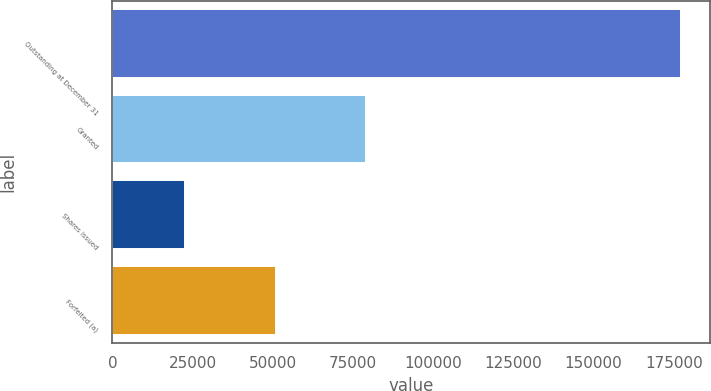Convert chart to OTSL. <chart><loc_0><loc_0><loc_500><loc_500><bar_chart><fcel>Outstanding at December 31<fcel>Granted<fcel>Shares issued<fcel>Forfeited (a)<nl><fcel>177250<fcel>78992<fcel>22700<fcel>50846<nl></chart> 